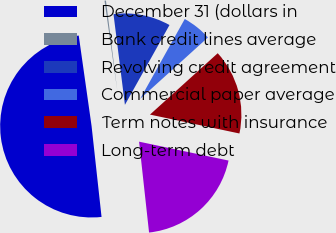<chart> <loc_0><loc_0><loc_500><loc_500><pie_chart><fcel>December 31 (dollars in<fcel>Bank credit lines average<fcel>Revolving credit agreement<fcel>Commercial paper average<fcel>Term notes with insurance<fcel>Long-term debt<nl><fcel>49.5%<fcel>0.25%<fcel>10.1%<fcel>5.18%<fcel>15.03%<fcel>19.95%<nl></chart> 